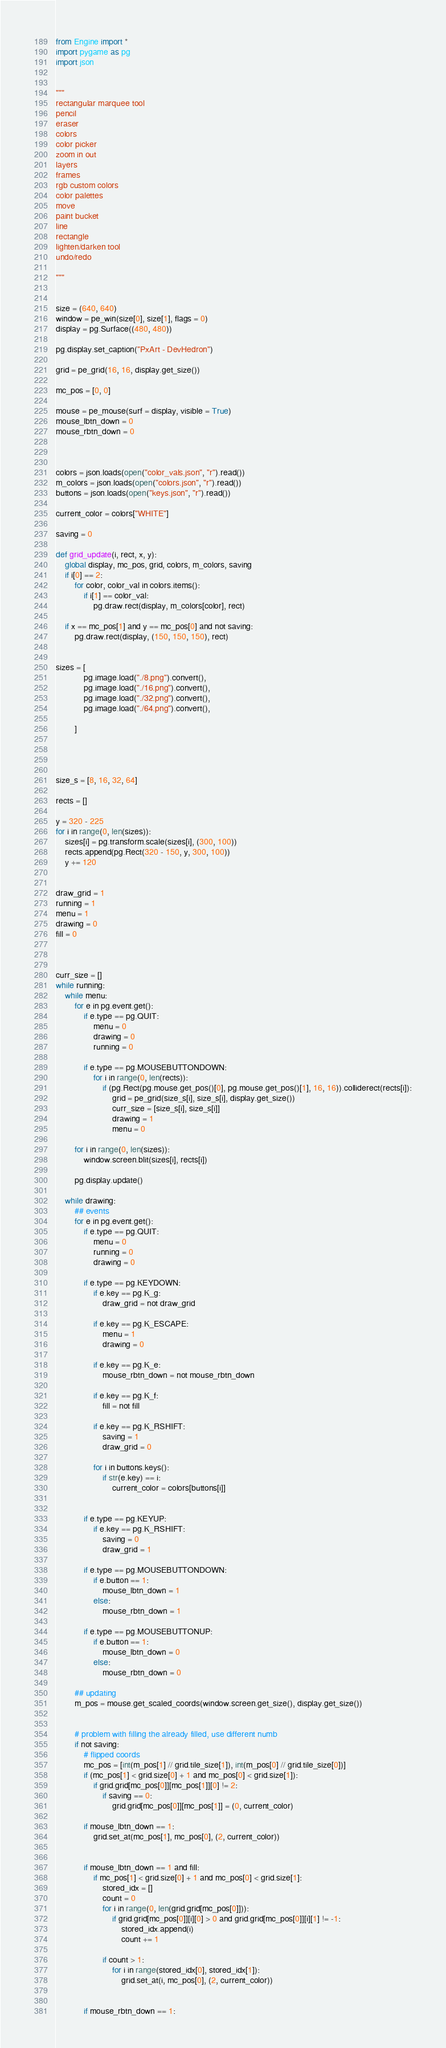<code> <loc_0><loc_0><loc_500><loc_500><_Python_>from Engine import *
import pygame as pg
import json


"""
rectangular marquee tool
pencil
eraser
colors
color picker
zoom in out
layers
frames
rgb custom colors
color palettes
move
paint bucket
line 
rectangle
lighten/darken tool
undo/redo

"""


size = (640, 640)
window = pe_win(size[0], size[1], flags = 0)
display = pg.Surface((480, 480))

pg.display.set_caption("PxArt - DevHedron")

grid = pe_grid(16, 16, display.get_size())

mc_pos = [0, 0]

mouse = pe_mouse(surf = display, visible = True)
mouse_lbtn_down = 0
mouse_rbtn_down = 0



colors = json.loads(open("color_vals.json", "r").read())
m_colors = json.loads(open("colors.json", "r").read())
buttons = json.loads(open("keys.json", "r").read())

current_color = colors["WHITE"]

saving = 0

def grid_update(i, rect, x, y):
    global display, mc_pos, grid, colors, m_colors, saving
    if i[0] == 2:
        for color, color_val in colors.items():
            if i[1] == color_val:
                pg.draw.rect(display, m_colors[color], rect)

    if x == mc_pos[1] and y == mc_pos[0] and not saving:
        pg.draw.rect(display, (150, 150, 150), rect)
    

sizes = [
            pg.image.load("./8.png").convert(),
            pg.image.load("./16.png").convert(),
            pg.image.load("./32.png").convert(),
            pg.image.load("./64.png").convert(),

        ]




size_s = [8, 16, 32, 64]

rects = []

y = 320 - 225
for i in range(0, len(sizes)):
    sizes[i] = pg.transform.scale(sizes[i], (300, 100))
    rects.append(pg.Rect(320 - 150, y, 300, 100))
    y += 120
    

draw_grid = 1
running = 1
menu = 1
drawing = 0
fill = 0



curr_size = []
while running:
    while menu:
        for e in pg.event.get():
            if e.type == pg.QUIT:
                menu = 0
                drawing = 0
                running = 0

            if e.type == pg.MOUSEBUTTONDOWN:
                for i in range(0, len(rects)):
                    if (pg.Rect(pg.mouse.get_pos()[0], pg.mouse.get_pos()[1], 16, 16)).colliderect(rects[i]):
                        grid = pe_grid(size_s[i], size_s[i], display.get_size())
                        curr_size = [size_s[i], size_s[i]]
                        drawing = 1
                        menu = 0

        for i in range(0, len(sizes)):
            window.screen.blit(sizes[i], rects[i])

        pg.display.update()

    while drawing:
        ## events
        for e in pg.event.get():
            if e.type == pg.QUIT:
                menu = 0
                running = 0
                drawing = 0

            if e.type == pg.KEYDOWN:
                if e.key == pg.K_g:
                    draw_grid = not draw_grid

                if e.key == pg.K_ESCAPE:
                    menu = 1
                    drawing = 0

                if e.key == pg.K_e:
                    mouse_rbtn_down = not mouse_rbtn_down

                if e.key == pg.K_f:
                    fill = not fill

                if e.key == pg.K_RSHIFT:
                    saving = 1
                    draw_grid = 0

                for i in buttons.keys():
                    if str(e.key) == i:
                        current_color = colors[buttons[i]]
                    

            if e.type == pg.KEYUP:
                if e.key == pg.K_RSHIFT:
                    saving = 0
                    draw_grid = 1

            if e.type == pg.MOUSEBUTTONDOWN:
                if e.button == 1:
                    mouse_lbtn_down = 1 
                else: 
                    mouse_rbtn_down = 1

            if e.type == pg.MOUSEBUTTONUP:
                if e.button == 1:
                    mouse_lbtn_down = 0
                else:
                    mouse_rbtn_down = 0

        ## updating
        m_pos = mouse.get_scaled_coords(window.screen.get_size(), display.get_size())


        # problem with filling the already filled, use different numb
        if not saving:
            # flipped coords
            mc_pos = [int(m_pos[1] // grid.tile_size[1]), int(m_pos[0] // grid.tile_size[0])] 
            if (mc_pos[1] < grid.size[0] + 1 and mc_pos[0] < grid.size[1]):
                if grid.grid[mc_pos[0]][mc_pos[1]][0] != 2:
                    if saving == 0:
                        grid.grid[mc_pos[0]][mc_pos[1]] = (0, current_color)

            if mouse_lbtn_down == 1:
                grid.set_at(mc_pos[1], mc_pos[0], (2, current_color)) 


            if mouse_lbtn_down == 1 and fill:
                if mc_pos[1] < grid.size[0] + 1 and mc_pos[0] < grid.size[1]:
                    stored_idx = []
                    count = 0
                    for i in range(0, len(grid.grid[mc_pos[0]])):
                        if grid.grid[mc_pos[0]][i][0] > 0 and grid.grid[mc_pos[0]][i][1] != -1:
                            stored_idx.append(i)
                            count += 1

                    if count > 1:
                        for i in range(stored_idx[0], stored_idx[1]):
                            grid.set_at(i, mc_pos[0], (2, current_color))


            if mouse_rbtn_down == 1:</code> 